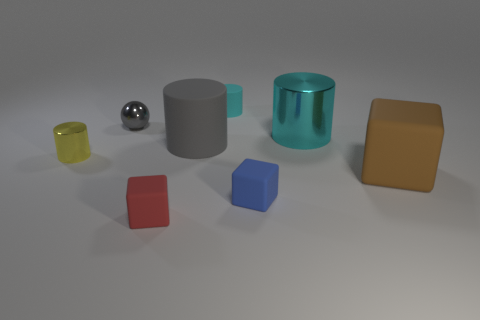Considering the colors of the objects, what can you infer about the color palette used in this image? The color palette of the image is quite varied yet harmonious, with muted tones that suggest a controlled and deliberate selection. The use of primary colors such as red, yellow, and blue is balanced with secondary colors like the cyan, and complemented by neutral tones such as the gray cylinder and white background. The palette is likely chosen to showcase the different materials and how they interact with light. 